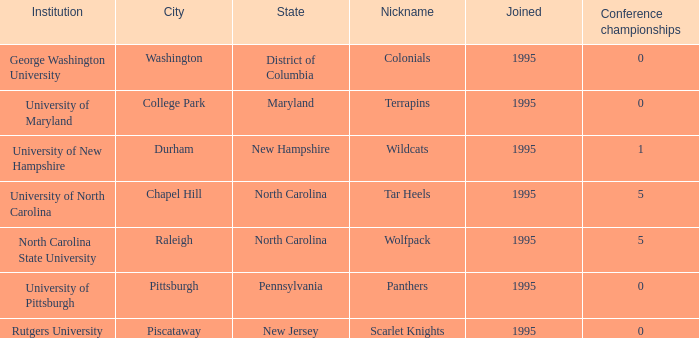What is the year joined with a Conference championships of 5, and a Nickname of wolfpack? 1995.0. 